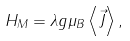Convert formula to latex. <formula><loc_0><loc_0><loc_500><loc_500>H _ { M } = \lambda g \mu _ { B } \left \langle \vec { J } \right \rangle ,</formula> 